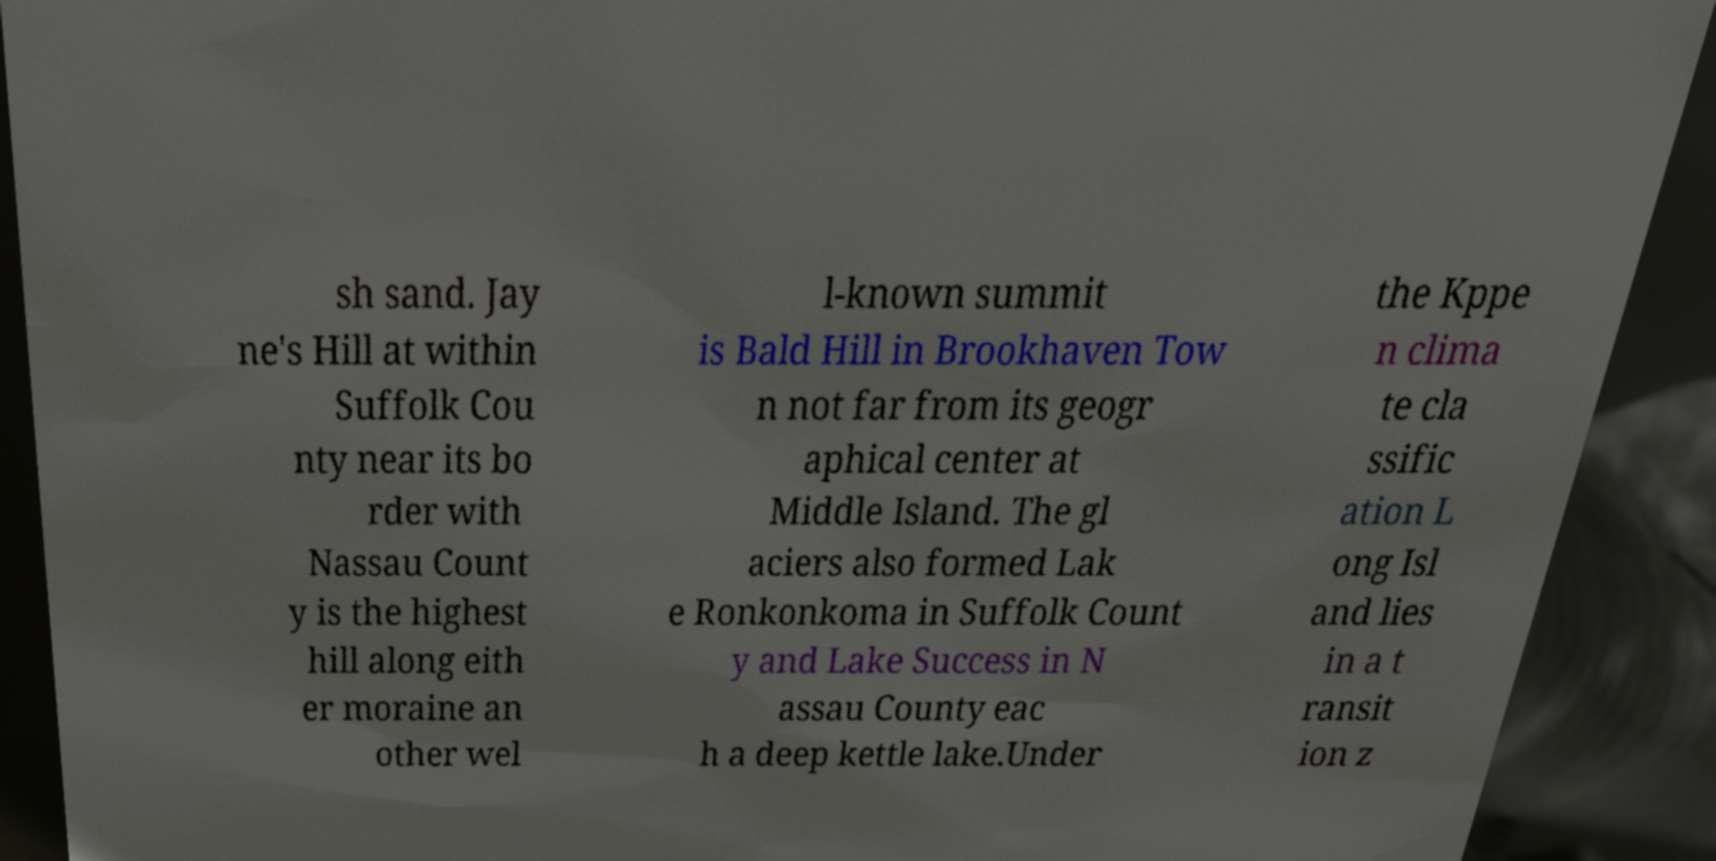I need the written content from this picture converted into text. Can you do that? sh sand. Jay ne's Hill at within Suffolk Cou nty near its bo rder with Nassau Count y is the highest hill along eith er moraine an other wel l-known summit is Bald Hill in Brookhaven Tow n not far from its geogr aphical center at Middle Island. The gl aciers also formed Lak e Ronkonkoma in Suffolk Count y and Lake Success in N assau County eac h a deep kettle lake.Under the Kppe n clima te cla ssific ation L ong Isl and lies in a t ransit ion z 